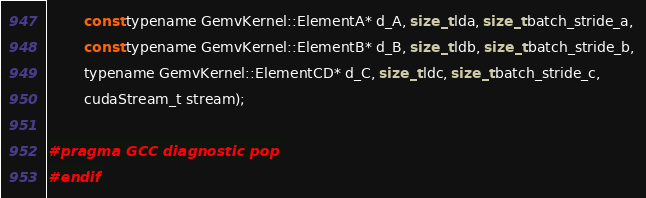Convert code to text. <code><loc_0><loc_0><loc_500><loc_500><_Cuda_>        const typename GemvKernel::ElementA* d_A, size_t lda, size_t batch_stride_a, 
        const typename GemvKernel::ElementB* d_B, size_t ldb, size_t batch_stride_b, 
        typename GemvKernel::ElementCD* d_C, size_t ldc, size_t batch_stride_c,
        cudaStream_t stream);

#pragma GCC diagnostic pop
#endif
</code> 